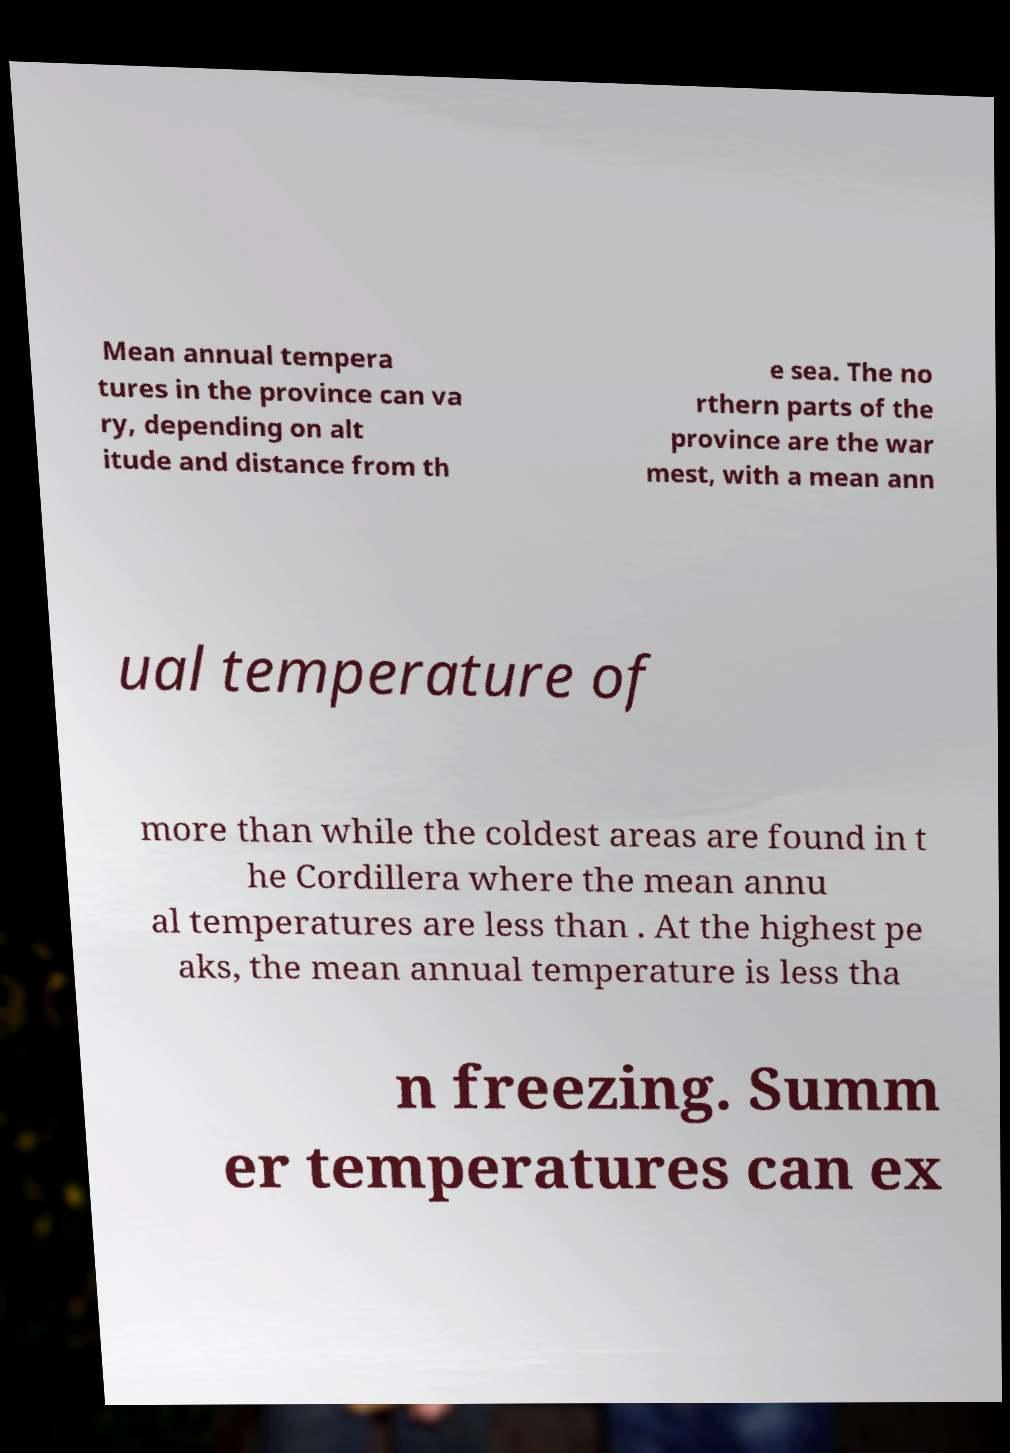I need the written content from this picture converted into text. Can you do that? Mean annual tempera tures in the province can va ry, depending on alt itude and distance from th e sea. The no rthern parts of the province are the war mest, with a mean ann ual temperature of more than while the coldest areas are found in t he Cordillera where the mean annu al temperatures are less than . At the highest pe aks, the mean annual temperature is less tha n freezing. Summ er temperatures can ex 